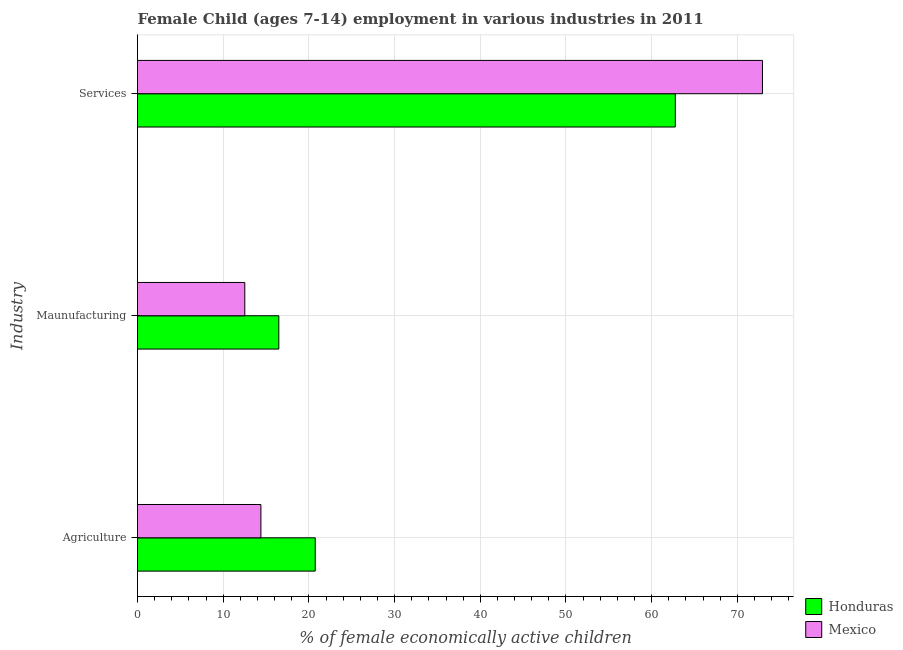How many different coloured bars are there?
Keep it short and to the point. 2. How many groups of bars are there?
Your answer should be compact. 3. Are the number of bars on each tick of the Y-axis equal?
Offer a very short reply. Yes. How many bars are there on the 3rd tick from the top?
Keep it short and to the point. 2. What is the label of the 3rd group of bars from the top?
Keep it short and to the point. Agriculture. What is the percentage of economically active children in services in Mexico?
Your answer should be very brief. 72.93. Across all countries, what is the maximum percentage of economically active children in services?
Offer a very short reply. 72.93. Across all countries, what is the minimum percentage of economically active children in services?
Ensure brevity in your answer.  62.76. In which country was the percentage of economically active children in manufacturing maximum?
Keep it short and to the point. Honduras. What is the total percentage of economically active children in services in the graph?
Give a very brief answer. 135.69. What is the difference between the percentage of economically active children in agriculture in Mexico and that in Honduras?
Provide a succinct answer. -6.34. What is the difference between the percentage of economically active children in agriculture in Honduras and the percentage of economically active children in services in Mexico?
Ensure brevity in your answer.  -52.19. What is the average percentage of economically active children in services per country?
Keep it short and to the point. 67.84. What is the difference between the percentage of economically active children in agriculture and percentage of economically active children in services in Honduras?
Provide a succinct answer. -42.02. In how many countries, is the percentage of economically active children in manufacturing greater than 50 %?
Make the answer very short. 0. What is the ratio of the percentage of economically active children in services in Honduras to that in Mexico?
Your answer should be compact. 0.86. Is the percentage of economically active children in manufacturing in Mexico less than that in Honduras?
Provide a short and direct response. Yes. Is the difference between the percentage of economically active children in services in Honduras and Mexico greater than the difference between the percentage of economically active children in manufacturing in Honduras and Mexico?
Make the answer very short. No. What is the difference between the highest and the second highest percentage of economically active children in agriculture?
Your answer should be compact. 6.34. What is the difference between the highest and the lowest percentage of economically active children in services?
Ensure brevity in your answer.  10.17. Is the sum of the percentage of economically active children in agriculture in Honduras and Mexico greater than the maximum percentage of economically active children in manufacturing across all countries?
Your response must be concise. Yes. What does the 2nd bar from the top in Maunufacturing represents?
Give a very brief answer. Honduras. What does the 2nd bar from the bottom in Maunufacturing represents?
Your answer should be compact. Mexico. Are all the bars in the graph horizontal?
Offer a terse response. Yes. What is the difference between two consecutive major ticks on the X-axis?
Your response must be concise. 10. Are the values on the major ticks of X-axis written in scientific E-notation?
Ensure brevity in your answer.  No. Does the graph contain grids?
Your response must be concise. Yes. Where does the legend appear in the graph?
Provide a succinct answer. Bottom right. How are the legend labels stacked?
Provide a succinct answer. Vertical. What is the title of the graph?
Keep it short and to the point. Female Child (ages 7-14) employment in various industries in 2011. What is the label or title of the X-axis?
Your response must be concise. % of female economically active children. What is the label or title of the Y-axis?
Give a very brief answer. Industry. What is the % of female economically active children of Honduras in Agriculture?
Your response must be concise. 20.74. What is the % of female economically active children in Honduras in Maunufacturing?
Give a very brief answer. 16.49. What is the % of female economically active children in Mexico in Maunufacturing?
Offer a terse response. 12.52. What is the % of female economically active children of Honduras in Services?
Your response must be concise. 62.76. What is the % of female economically active children of Mexico in Services?
Your response must be concise. 72.93. Across all Industry, what is the maximum % of female economically active children in Honduras?
Your response must be concise. 62.76. Across all Industry, what is the maximum % of female economically active children of Mexico?
Offer a very short reply. 72.93. Across all Industry, what is the minimum % of female economically active children in Honduras?
Your answer should be compact. 16.49. Across all Industry, what is the minimum % of female economically active children in Mexico?
Make the answer very short. 12.52. What is the total % of female economically active children in Honduras in the graph?
Your answer should be compact. 99.99. What is the total % of female economically active children in Mexico in the graph?
Keep it short and to the point. 99.85. What is the difference between the % of female economically active children of Honduras in Agriculture and that in Maunufacturing?
Ensure brevity in your answer.  4.25. What is the difference between the % of female economically active children of Mexico in Agriculture and that in Maunufacturing?
Offer a very short reply. 1.88. What is the difference between the % of female economically active children in Honduras in Agriculture and that in Services?
Your answer should be compact. -42.02. What is the difference between the % of female economically active children in Mexico in Agriculture and that in Services?
Your response must be concise. -58.53. What is the difference between the % of female economically active children in Honduras in Maunufacturing and that in Services?
Give a very brief answer. -46.27. What is the difference between the % of female economically active children in Mexico in Maunufacturing and that in Services?
Your response must be concise. -60.41. What is the difference between the % of female economically active children in Honduras in Agriculture and the % of female economically active children in Mexico in Maunufacturing?
Ensure brevity in your answer.  8.22. What is the difference between the % of female economically active children in Honduras in Agriculture and the % of female economically active children in Mexico in Services?
Provide a short and direct response. -52.19. What is the difference between the % of female economically active children of Honduras in Maunufacturing and the % of female economically active children of Mexico in Services?
Make the answer very short. -56.44. What is the average % of female economically active children in Honduras per Industry?
Offer a terse response. 33.33. What is the average % of female economically active children of Mexico per Industry?
Provide a succinct answer. 33.28. What is the difference between the % of female economically active children in Honduras and % of female economically active children in Mexico in Agriculture?
Your answer should be compact. 6.34. What is the difference between the % of female economically active children of Honduras and % of female economically active children of Mexico in Maunufacturing?
Your response must be concise. 3.97. What is the difference between the % of female economically active children of Honduras and % of female economically active children of Mexico in Services?
Provide a short and direct response. -10.17. What is the ratio of the % of female economically active children in Honduras in Agriculture to that in Maunufacturing?
Ensure brevity in your answer.  1.26. What is the ratio of the % of female economically active children of Mexico in Agriculture to that in Maunufacturing?
Provide a succinct answer. 1.15. What is the ratio of the % of female economically active children of Honduras in Agriculture to that in Services?
Keep it short and to the point. 0.33. What is the ratio of the % of female economically active children in Mexico in Agriculture to that in Services?
Make the answer very short. 0.2. What is the ratio of the % of female economically active children of Honduras in Maunufacturing to that in Services?
Your response must be concise. 0.26. What is the ratio of the % of female economically active children of Mexico in Maunufacturing to that in Services?
Ensure brevity in your answer.  0.17. What is the difference between the highest and the second highest % of female economically active children in Honduras?
Your response must be concise. 42.02. What is the difference between the highest and the second highest % of female economically active children in Mexico?
Offer a very short reply. 58.53. What is the difference between the highest and the lowest % of female economically active children of Honduras?
Provide a succinct answer. 46.27. What is the difference between the highest and the lowest % of female economically active children in Mexico?
Your answer should be very brief. 60.41. 